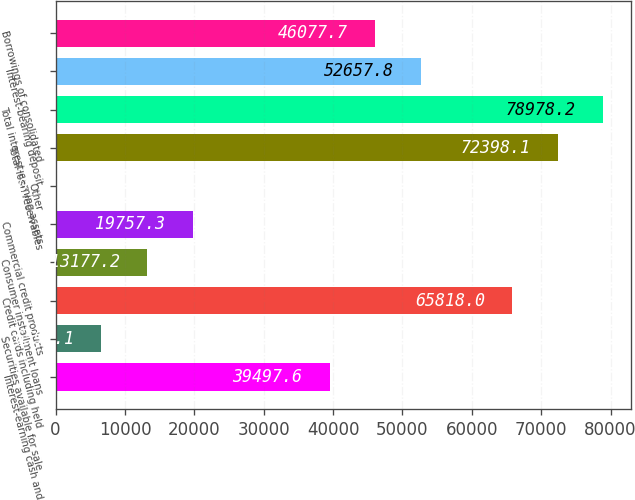Convert chart. <chart><loc_0><loc_0><loc_500><loc_500><bar_chart><fcel>Interest-earning cash and<fcel>Securities available for sale<fcel>Credit cards including held<fcel>Consumer installment loans<fcel>Commercial credit products<fcel>Other<fcel>Total loan receivables<fcel>Total interest-earning assets<fcel>Interest-bearing deposit<fcel>Borrowings of consolidated<nl><fcel>39497.6<fcel>6597.1<fcel>65818<fcel>13177.2<fcel>19757.3<fcel>17<fcel>72398.1<fcel>78978.2<fcel>52657.8<fcel>46077.7<nl></chart> 